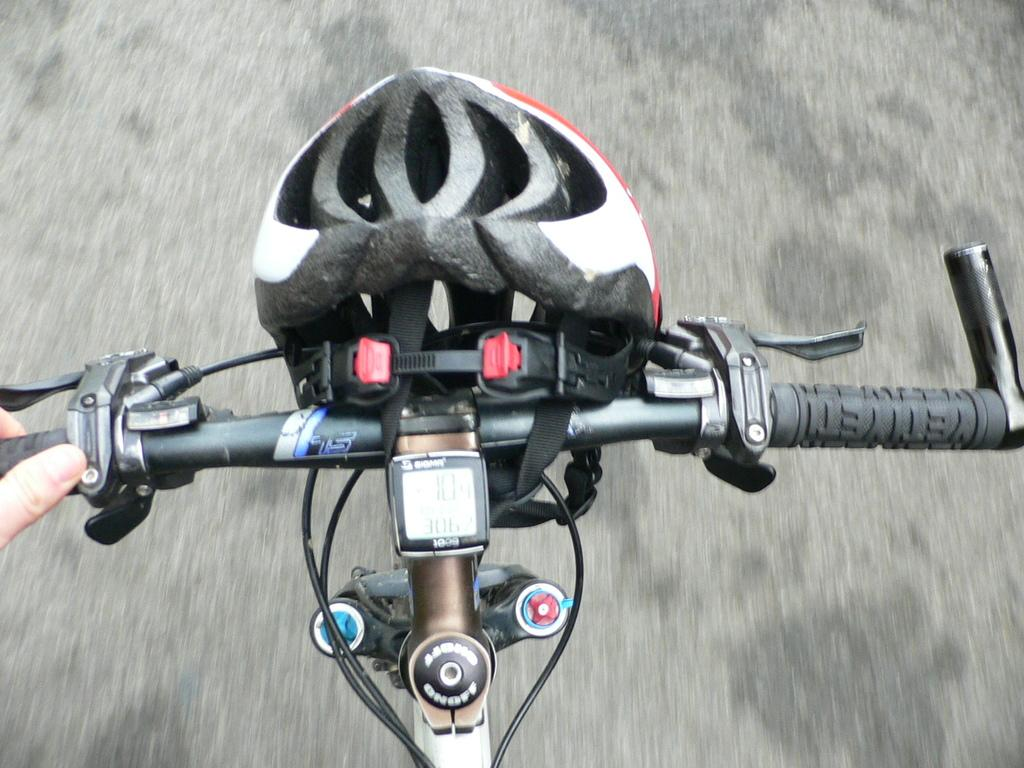What is the main subject of the image? There is a person in the image. What is the person doing in the image? The person is riding a cycle. Can you describe any safety equipment in the image? There is a helmet hanging on the handle of the cycle. What type of interest does the person have in the image? There is no information about the person's interests in the image. Can you tell me if the person is a slave in the image? There is no indication of slavery or any form of servitude in the image. 